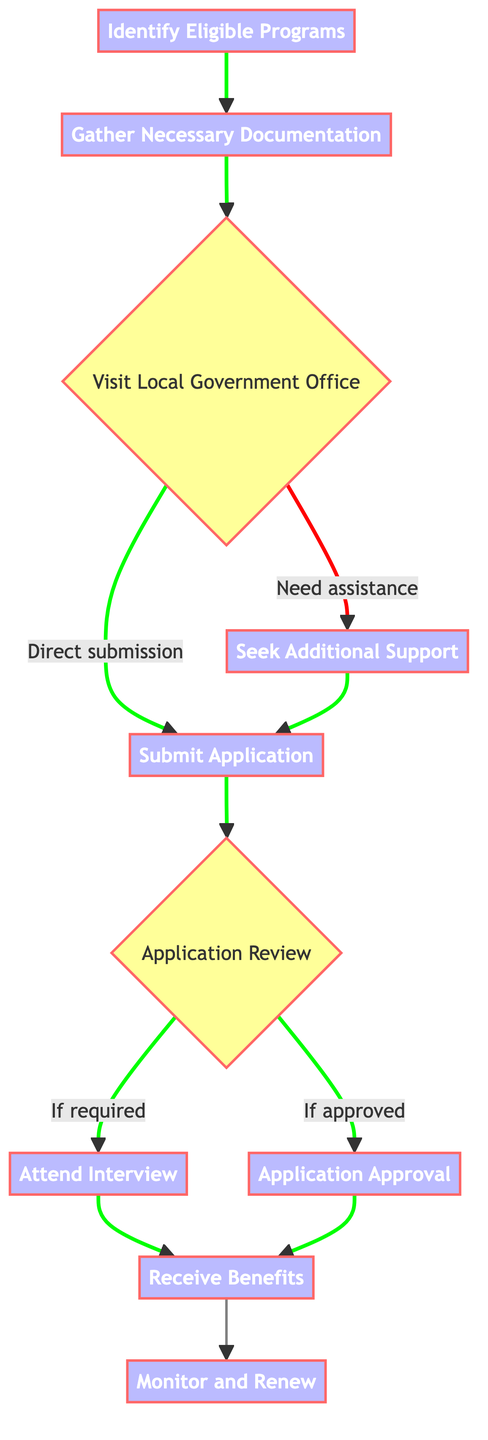What is the first step in the process? The first step is clearly indicated as "Identify Eligible Programs," which is represented as the initial node in the diagram.
Answer: Identify Eligible Programs How many total steps are included in the process? By counting the nodes in the diagram, we see there are a total of 10 steps.
Answer: 10 What comes after "Gather Necessary Documentation"? The diagram shows that after "Gather Necessary Documentation," the next step is "Visit Local Government Office."
Answer: Visit Local Government Office If assistance is needed, which step should one go to next? The diagram indicates that if assistance is needed, one should proceed to "Seek Additional Support," and then they can return to "Submit Application."
Answer: Seek Additional Support What happens if the application is approved? The diagram indicates that if the application is approved, the next step is to "Receive Benefits."
Answer: Receive Benefits How many decision nodes are present in the flowchart? The flowchart has 3 decision nodes, which include "Visit Local Government Office," "Application Review," and "Attend Interview."
Answer: 3 What is the final step in the process? The final step of the process as per the diagram is "Monitor and Renew."
Answer: Monitor and Renew At which stage does one attend an interview? According to the flowchart, one attends an interview after the "Application Review" if required.
Answer: Attend Interview What node should a person follow after submitting their application? After submitting their application, the next node to follow is "Application Review."
Answer: Application Review 